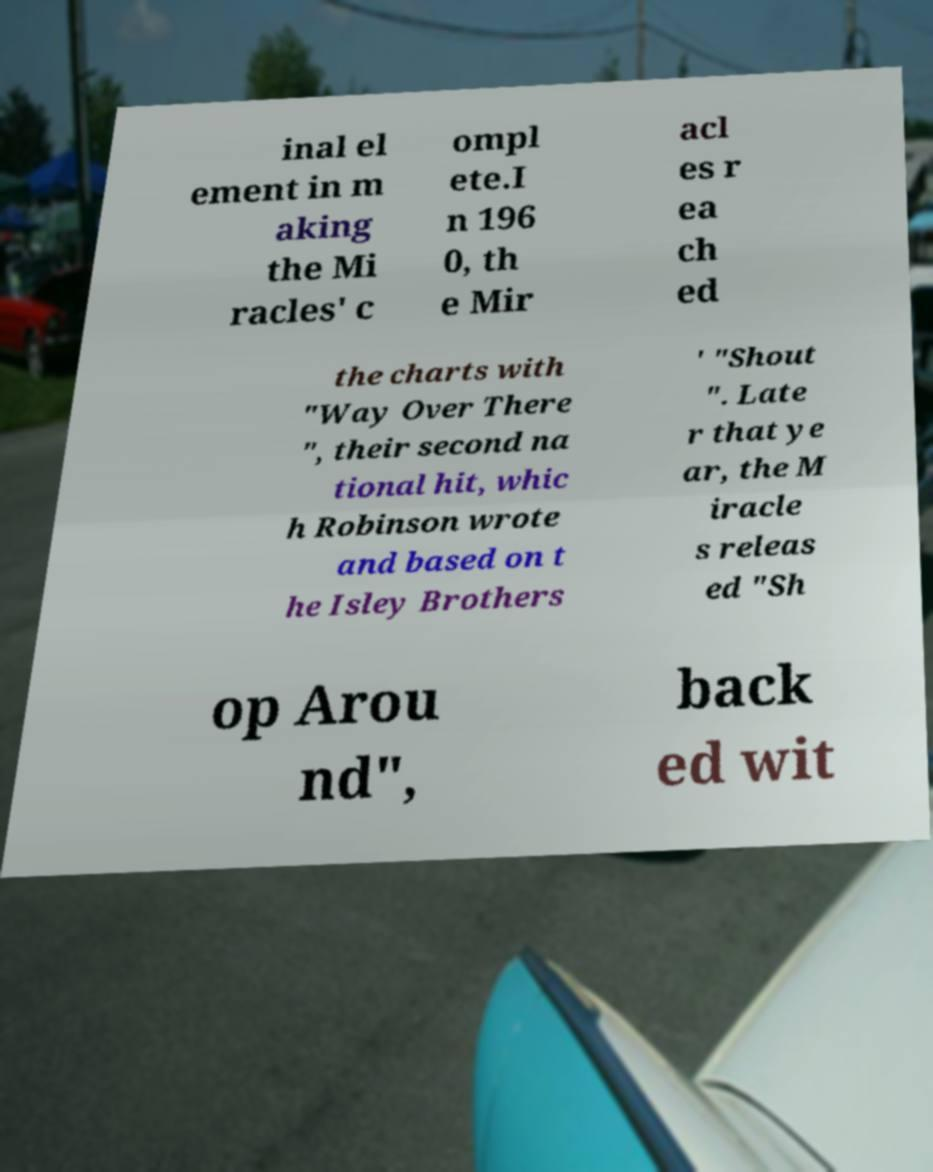Please read and relay the text visible in this image. What does it say? inal el ement in m aking the Mi racles' c ompl ete.I n 196 0, th e Mir acl es r ea ch ed the charts with "Way Over There ", their second na tional hit, whic h Robinson wrote and based on t he Isley Brothers ' "Shout ". Late r that ye ar, the M iracle s releas ed "Sh op Arou nd", back ed wit 